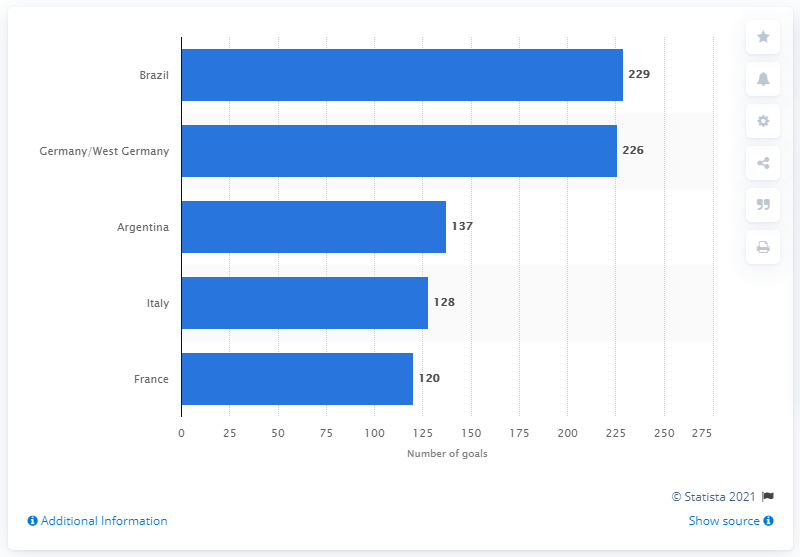What does this chart tell us about the historical performance of national football teams? The chart illustrates the cumulative number of goals scored by various national football teams in World Cup history. It indicates that Brazil has had a particularly strong offensive record, followed closely by Germany. These statistics suggest a consistent level of high performance by these countries in the international arena. Can you explain the significance of these numbers for a team's legacy? Certainly! The number of goals scored is a direct indicator of a team's attacking prowess and ability to perform under pressure in the world's most prestigious football tournament. A high number of goals, sustained over multiple World Cup editions, contributes to a team's legacy by showcasing their dominance and consistent excellence over time. It also reflects the skill of their players and the effectiveness of their strategies. 